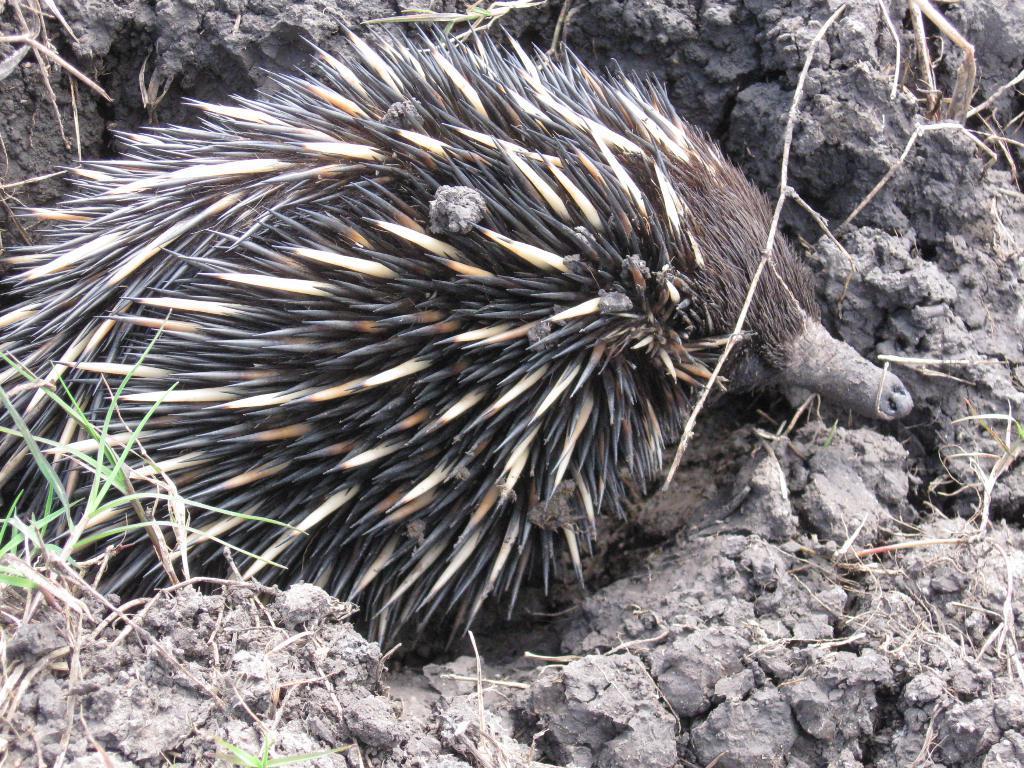Could you give a brief overview of what you see in this image? This image consists of an animal which is in the center. 